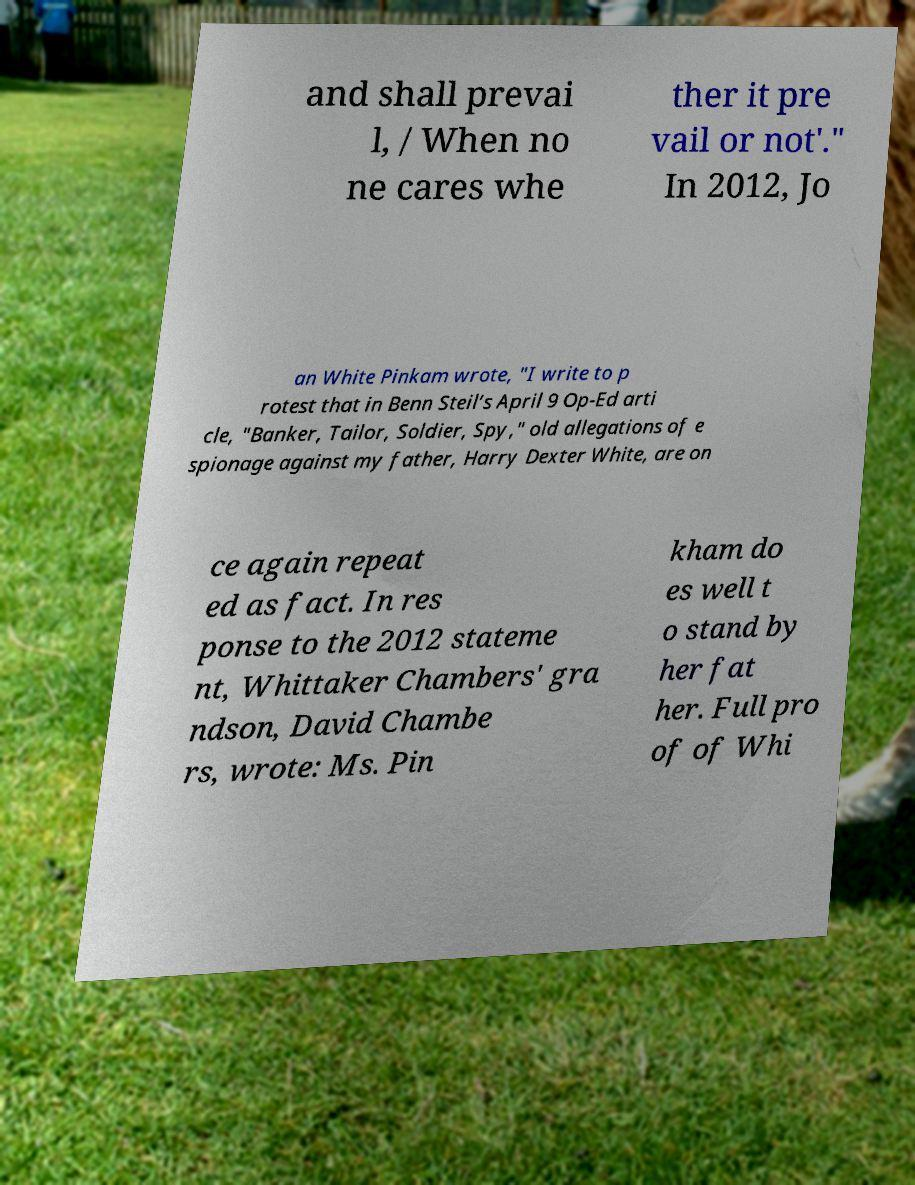Please identify and transcribe the text found in this image. and shall prevai l, / When no ne cares whe ther it pre vail or not'." In 2012, Jo an White Pinkam wrote, "I write to p rotest that in Benn Steil’s April 9 Op-Ed arti cle, "Banker, Tailor, Soldier, Spy," old allegations of e spionage against my father, Harry Dexter White, are on ce again repeat ed as fact. In res ponse to the 2012 stateme nt, Whittaker Chambers' gra ndson, David Chambe rs, wrote: Ms. Pin kham do es well t o stand by her fat her. Full pro of of Whi 